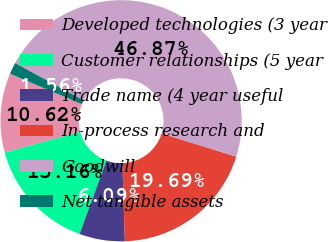Convert chart to OTSL. <chart><loc_0><loc_0><loc_500><loc_500><pie_chart><fcel>Developed technologies (3 year<fcel>Customer relationships (5 year<fcel>Trade name (4 year useful<fcel>In-process research and<fcel>Goodwill<fcel>Net tangible assets<nl><fcel>10.62%<fcel>15.16%<fcel>6.09%<fcel>19.69%<fcel>46.87%<fcel>1.56%<nl></chart> 